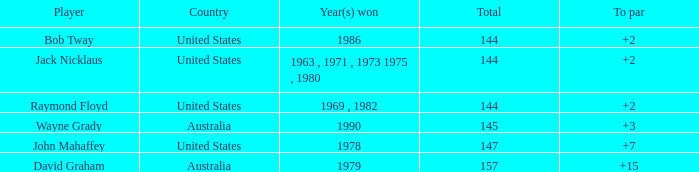What was the winner's score in relation to par in 1978? 7.0. 